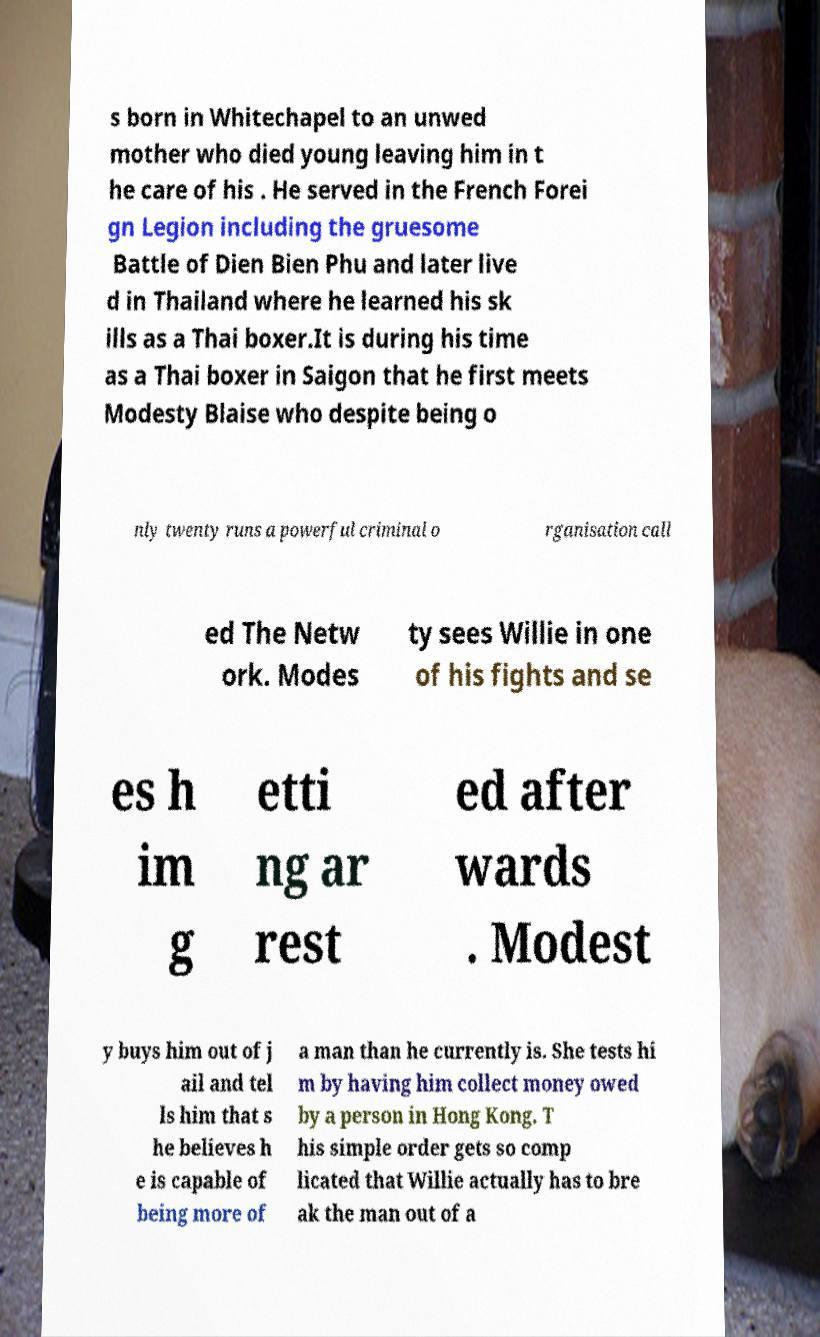Please read and relay the text visible in this image. What does it say? s born in Whitechapel to an unwed mother who died young leaving him in t he care of his . He served in the French Forei gn Legion including the gruesome Battle of Dien Bien Phu and later live d in Thailand where he learned his sk ills as a Thai boxer.It is during his time as a Thai boxer in Saigon that he first meets Modesty Blaise who despite being o nly twenty runs a powerful criminal o rganisation call ed The Netw ork. Modes ty sees Willie in one of his fights and se es h im g etti ng ar rest ed after wards . Modest y buys him out of j ail and tel ls him that s he believes h e is capable of being more of a man than he currently is. She tests hi m by having him collect money owed by a person in Hong Kong. T his simple order gets so comp licated that Willie actually has to bre ak the man out of a 